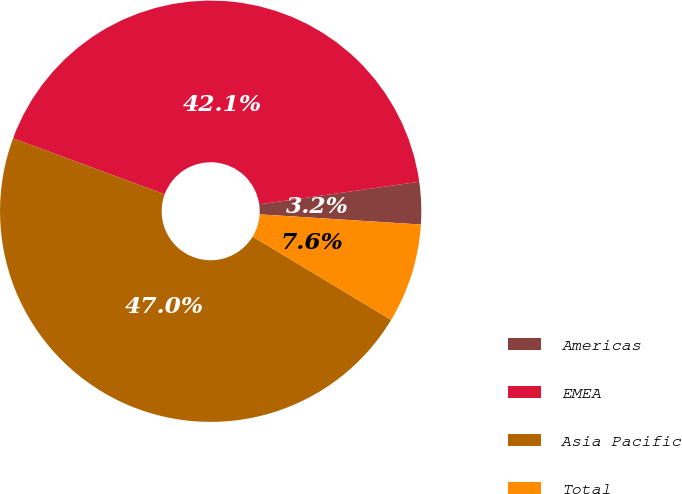Convert chart to OTSL. <chart><loc_0><loc_0><loc_500><loc_500><pie_chart><fcel>Americas<fcel>EMEA<fcel>Asia Pacific<fcel>Total<nl><fcel>3.24%<fcel>42.14%<fcel>47.0%<fcel>7.62%<nl></chart> 